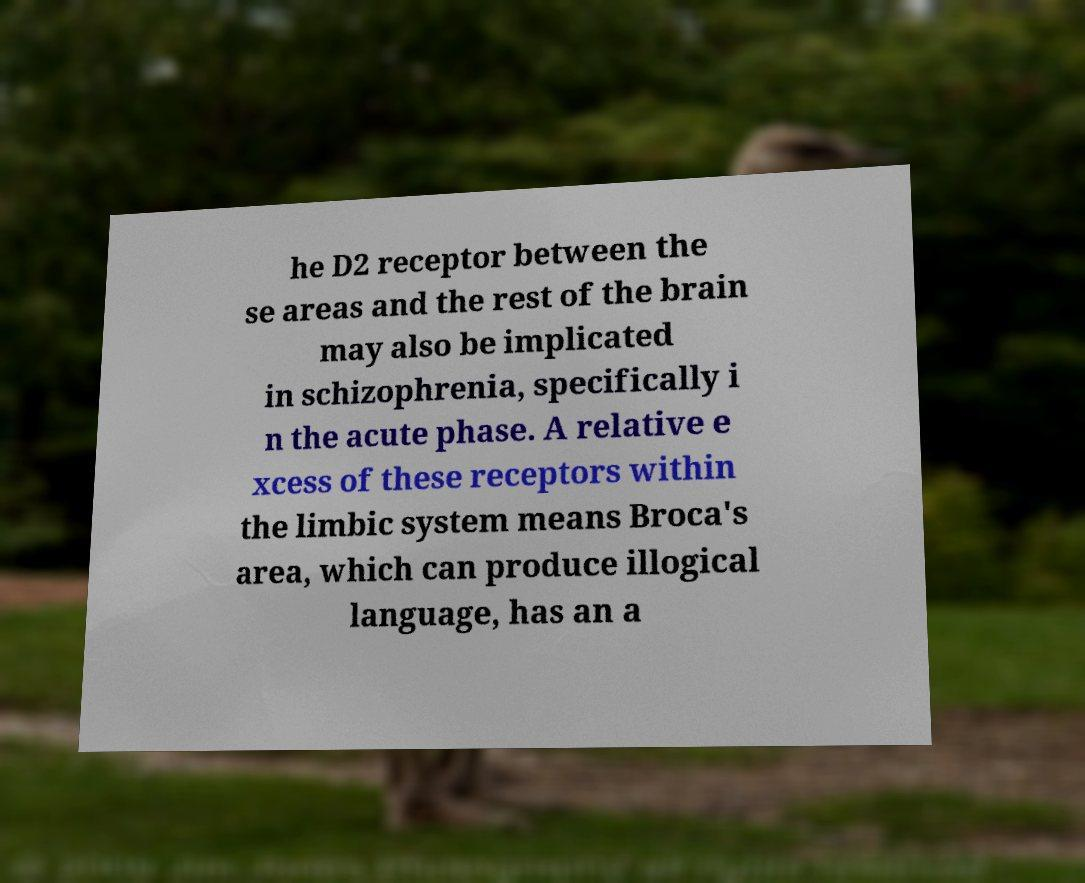There's text embedded in this image that I need extracted. Can you transcribe it verbatim? he D2 receptor between the se areas and the rest of the brain may also be implicated in schizophrenia, specifically i n the acute phase. A relative e xcess of these receptors within the limbic system means Broca's area, which can produce illogical language, has an a 